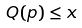Convert formula to latex. <formula><loc_0><loc_0><loc_500><loc_500>Q ( p ) \leq x</formula> 